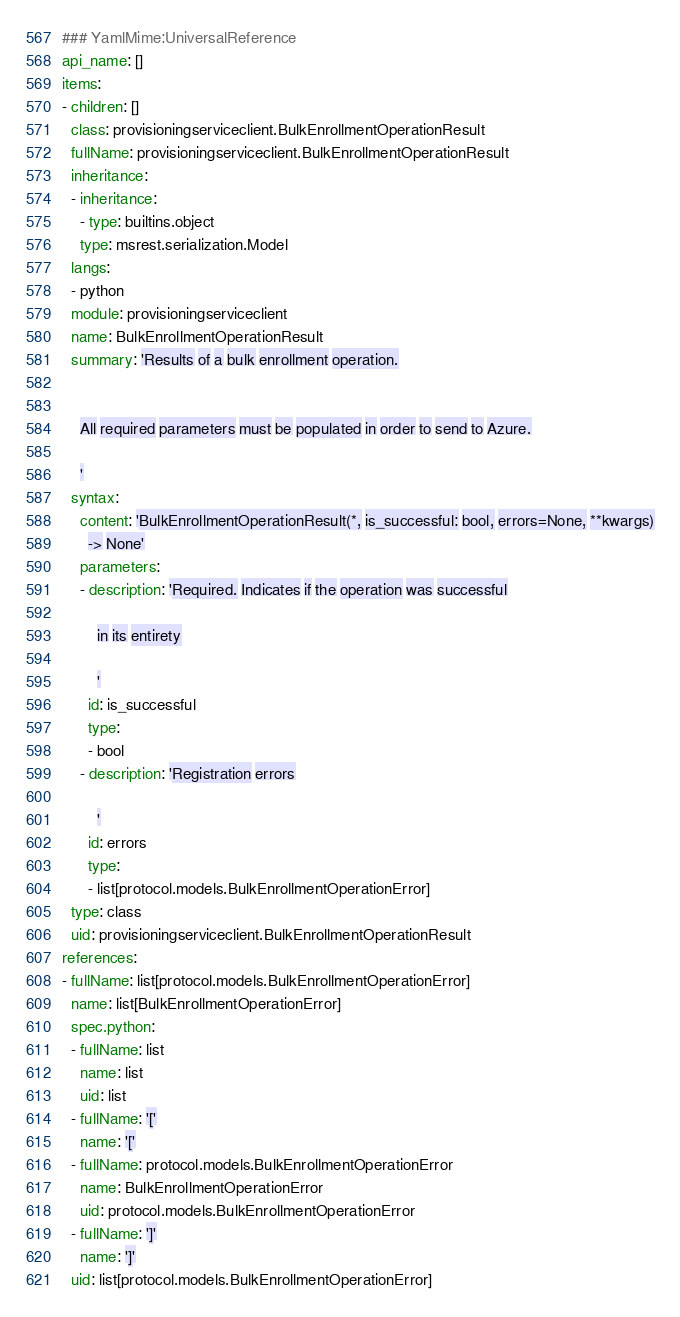<code> <loc_0><loc_0><loc_500><loc_500><_YAML_>### YamlMime:UniversalReference
api_name: []
items:
- children: []
  class: provisioningserviceclient.BulkEnrollmentOperationResult
  fullName: provisioningserviceclient.BulkEnrollmentOperationResult
  inheritance:
  - inheritance:
    - type: builtins.object
    type: msrest.serialization.Model
  langs:
  - python
  module: provisioningserviceclient
  name: BulkEnrollmentOperationResult
  summary: 'Results of a bulk enrollment operation.


    All required parameters must be populated in order to send to Azure.

    '
  syntax:
    content: 'BulkEnrollmentOperationResult(*, is_successful: bool, errors=None, **kwargs)
      -> None'
    parameters:
    - description: 'Required. Indicates if the operation was successful

        in its entirety

        '
      id: is_successful
      type:
      - bool
    - description: 'Registration errors

        '
      id: errors
      type:
      - list[protocol.models.BulkEnrollmentOperationError]
  type: class
  uid: provisioningserviceclient.BulkEnrollmentOperationResult
references:
- fullName: list[protocol.models.BulkEnrollmentOperationError]
  name: list[BulkEnrollmentOperationError]
  spec.python:
  - fullName: list
    name: list
    uid: list
  - fullName: '['
    name: '['
  - fullName: protocol.models.BulkEnrollmentOperationError
    name: BulkEnrollmentOperationError
    uid: protocol.models.BulkEnrollmentOperationError
  - fullName: ']'
    name: ']'
  uid: list[protocol.models.BulkEnrollmentOperationError]
</code> 